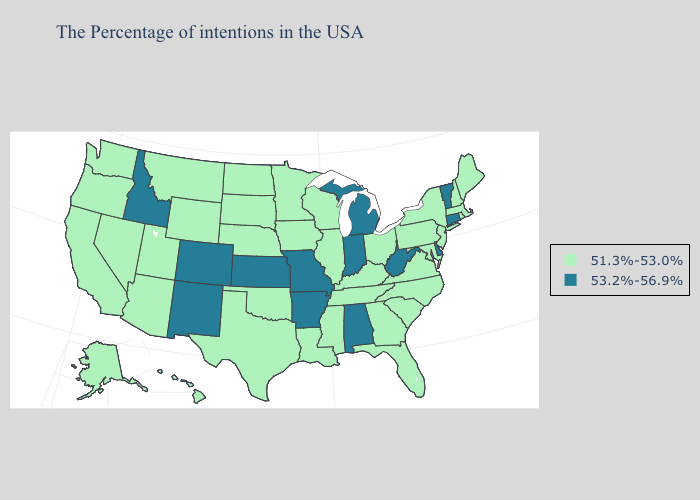Which states have the highest value in the USA?
Keep it brief. Vermont, Connecticut, Delaware, West Virginia, Michigan, Indiana, Alabama, Missouri, Arkansas, Kansas, Colorado, New Mexico, Idaho. Among the states that border Washington , does Oregon have the highest value?
Short answer required. No. Name the states that have a value in the range 53.2%-56.9%?
Answer briefly. Vermont, Connecticut, Delaware, West Virginia, Michigan, Indiana, Alabama, Missouri, Arkansas, Kansas, Colorado, New Mexico, Idaho. Does Delaware have the lowest value in the USA?
Short answer required. No. Which states have the lowest value in the West?
Quick response, please. Wyoming, Utah, Montana, Arizona, Nevada, California, Washington, Oregon, Alaska, Hawaii. Does the map have missing data?
Short answer required. No. Does Indiana have a higher value than Missouri?
Give a very brief answer. No. What is the value of Wyoming?
Concise answer only. 51.3%-53.0%. Which states have the highest value in the USA?
Short answer required. Vermont, Connecticut, Delaware, West Virginia, Michigan, Indiana, Alabama, Missouri, Arkansas, Kansas, Colorado, New Mexico, Idaho. Is the legend a continuous bar?
Be succinct. No. Does Wisconsin have the same value as Arizona?
Concise answer only. Yes. What is the value of North Carolina?
Concise answer only. 51.3%-53.0%. Does the map have missing data?
Be succinct. No. 